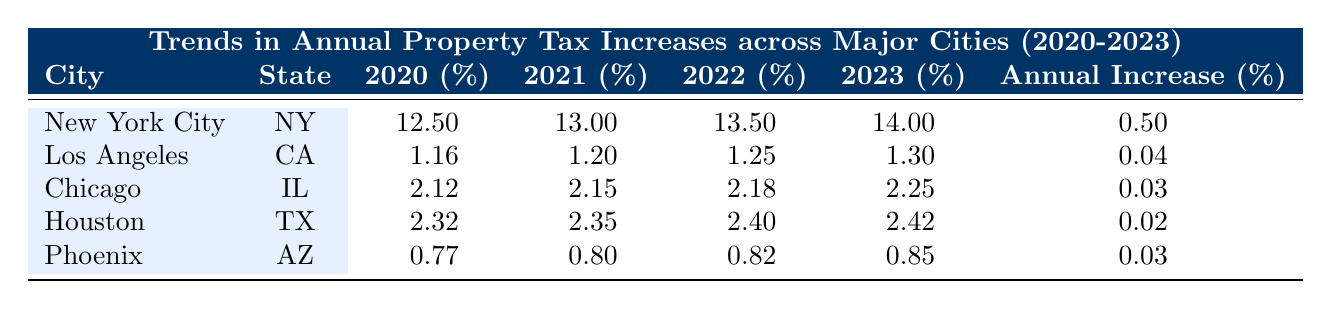What was the annual property tax rate percentage for New York City in 2021? The table lists the property tax rates for New York City for each year. Referring to the column for the year 2021, it shows 13.0%.
Answer: 13.0% Which city experienced the highest property tax rate increase from 2020 to 2023? For each city, we look at the tax rates for 2020 and 2023: New York City increased from 12.5% to 14.0%, which is a difference of 1.5%. The other cities did not have increases this high.
Answer: New York City What is the total property tax rate percentage for Phoenix from 2020 to 2023? Adding the property tax rates across the years for Phoenix yields: 0.77 + 0.80 + 0.82 + 0.85 = 3.24%.
Answer: 3.24% Did the property tax rate for Chicago decrease in any year between 2020 and 2023? The table shows the rate for Chicago increased every year: 2.12% in 2020, 2.15% in 2021, 2.18% in 2022, and 2.25% in 2023. This indicates there were no decreases.
Answer: No What was the average annual increase percentage of property tax rates for all cities from 2020 to 2023? We sum the annual increase percentages: 0.50 (NYC) + 0.04 (LA) + 0.03 (Chicago) + 0.02 (Houston) + 0.03 (Phoenix) = 0.62%. There are 5 cities, so the average is 0.62/5 = 0.124%.
Answer: 0.124% Which states had a property tax rate percentage of 2.00% or higher in 2023? Checking the 2023 tax rate column, we see the cities of New York City (14.0%), Chicago (2.25%), and Houston (2.42%) have rates 2.00% or higher. Los Angeles and Phoenix do not.
Answer: New York City, Chicago, Houston In what year did Los Angeles have the lowest property tax rate percentage? Looking at the percentage rates listed for Los Angeles, the year 2020 shows the lowest rate at 1.16%.
Answer: 2020 How much did property tax rates for Houston increase from 2022 to 2023? The property tax rate in Houston was 2.40% in 2022 and increased to 2.42% in 2023. The increase is 2.42% - 2.40% = 0.02%.
Answer: 0.02% 